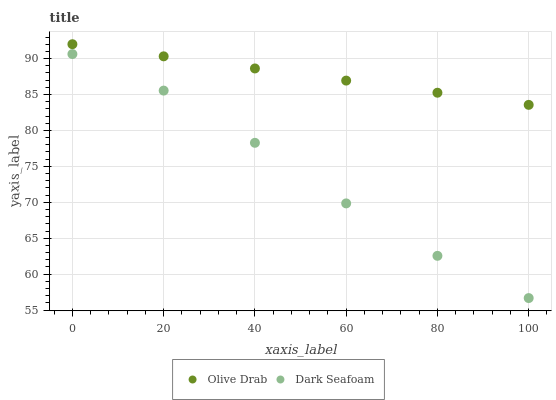Does Dark Seafoam have the minimum area under the curve?
Answer yes or no. Yes. Does Olive Drab have the maximum area under the curve?
Answer yes or no. Yes. Does Olive Drab have the minimum area under the curve?
Answer yes or no. No. Is Olive Drab the smoothest?
Answer yes or no. Yes. Is Dark Seafoam the roughest?
Answer yes or no. Yes. Is Olive Drab the roughest?
Answer yes or no. No. Does Dark Seafoam have the lowest value?
Answer yes or no. Yes. Does Olive Drab have the lowest value?
Answer yes or no. No. Does Olive Drab have the highest value?
Answer yes or no. Yes. Is Dark Seafoam less than Olive Drab?
Answer yes or no. Yes. Is Olive Drab greater than Dark Seafoam?
Answer yes or no. Yes. Does Dark Seafoam intersect Olive Drab?
Answer yes or no. No. 